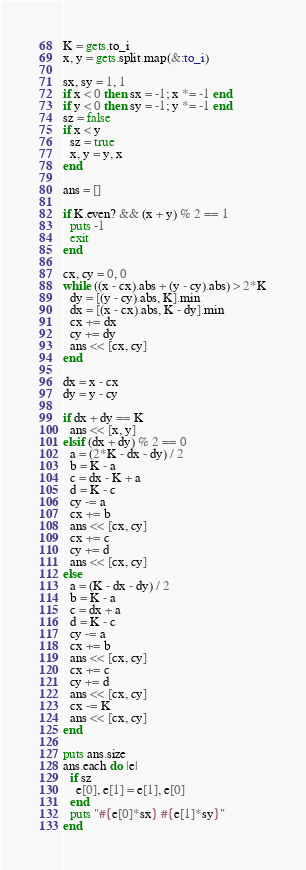Convert code to text. <code><loc_0><loc_0><loc_500><loc_500><_Ruby_>K = gets.to_i
x, y = gets.split.map(&:to_i)

sx, sy = 1, 1
if x < 0 then sx = -1; x *= -1 end
if y < 0 then sy = -1; y *= -1 end
sz = false
if x < y
  sz = true
  x, y = y, x
end

ans = []

if K.even? && (x + y) % 2 == 1
  puts -1
  exit
end

cx, cy = 0, 0
while ((x - cx).abs + (y - cy).abs) > 2*K
  dy = [(y - cy).abs, K].min
  dx = [(x - cx).abs, K - dy].min
  cx += dx
  cy += dy
  ans << [cx, cy]
end

dx = x - cx
dy = y - cy

if dx + dy == K
  ans << [x, y]
elsif (dx + dy) % 2 == 0
  a = (2*K - dx - dy) / 2
  b = K - a
  c = dx - K + a
  d = K - c
  cy -= a
  cx += b
  ans << [cx, cy]
  cx += c
  cy += d
  ans << [cx, cy]
else
  a = (K - dx - dy) / 2
  b = K - a
  c = dx + a
  d = K - c
  cy -= a
  cx += b
  ans << [cx, cy]
  cx += c
  cy += d
  ans << [cx, cy]
  cx -= K
  ans << [cx, cy]
end

puts ans.size
ans.each do |e|
  if sz
    e[0], e[1] = e[1], e[0]
  end
  puts "#{e[0]*sx} #{e[1]*sy}"
end</code> 